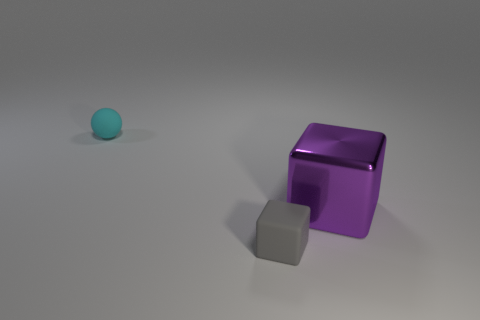There is a gray thing that is the same size as the cyan sphere; what shape is it?
Make the answer very short. Cube. Are there any tiny rubber cubes that have the same color as the metallic object?
Provide a short and direct response. No. Is the color of the metallic thing the same as the small matte thing that is in front of the small ball?
Make the answer very short. No. The small thing to the right of the tiny object that is behind the large purple metal cube is what color?
Give a very brief answer. Gray. There is a tiny rubber thing left of the tiny thing that is in front of the metallic cube; are there any purple metal objects that are on the left side of it?
Keep it short and to the point. No. There is a cube that is made of the same material as the cyan thing; what is its color?
Offer a terse response. Gray. What number of other large blocks are the same material as the purple cube?
Offer a very short reply. 0. Does the large block have the same material as the small object on the right side of the small cyan thing?
Give a very brief answer. No. What number of objects are small objects that are left of the small gray rubber cube or tiny things?
Make the answer very short. 2. What size is the object that is behind the large purple object that is in front of the rubber thing that is to the left of the small gray block?
Give a very brief answer. Small. 